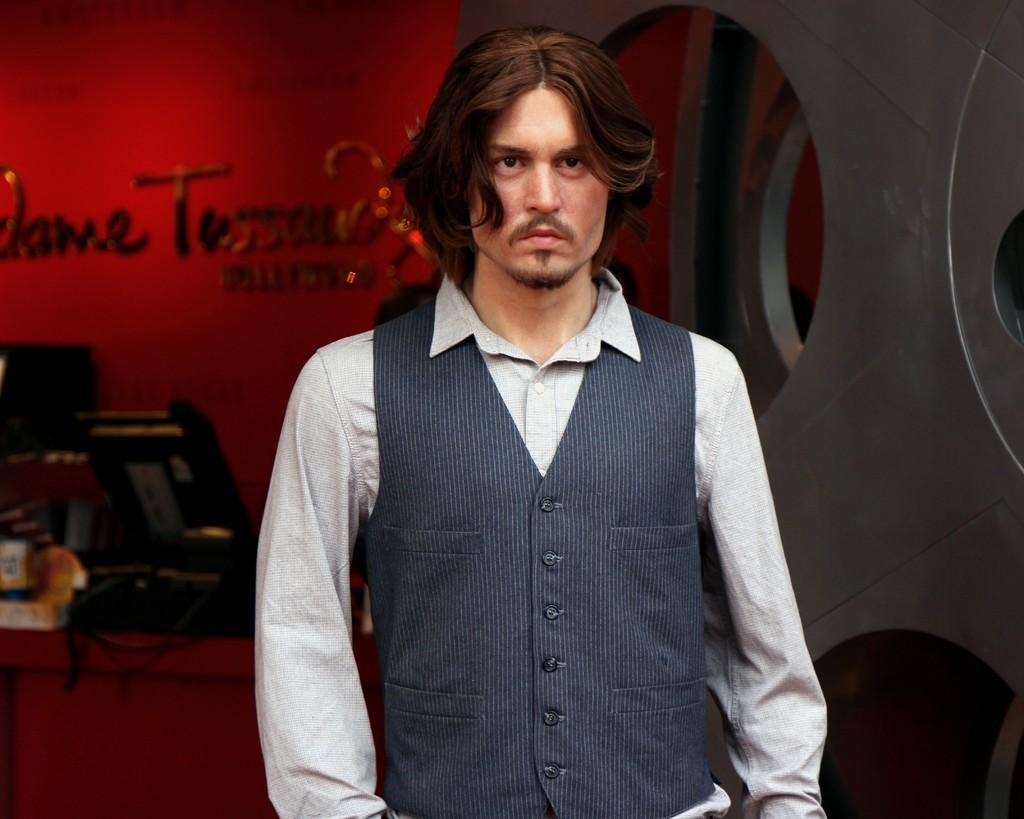Could you give a brief overview of what you see in this image? In this image there is a man standing, behind him there is a red color wall with some text and some things in front of that. 